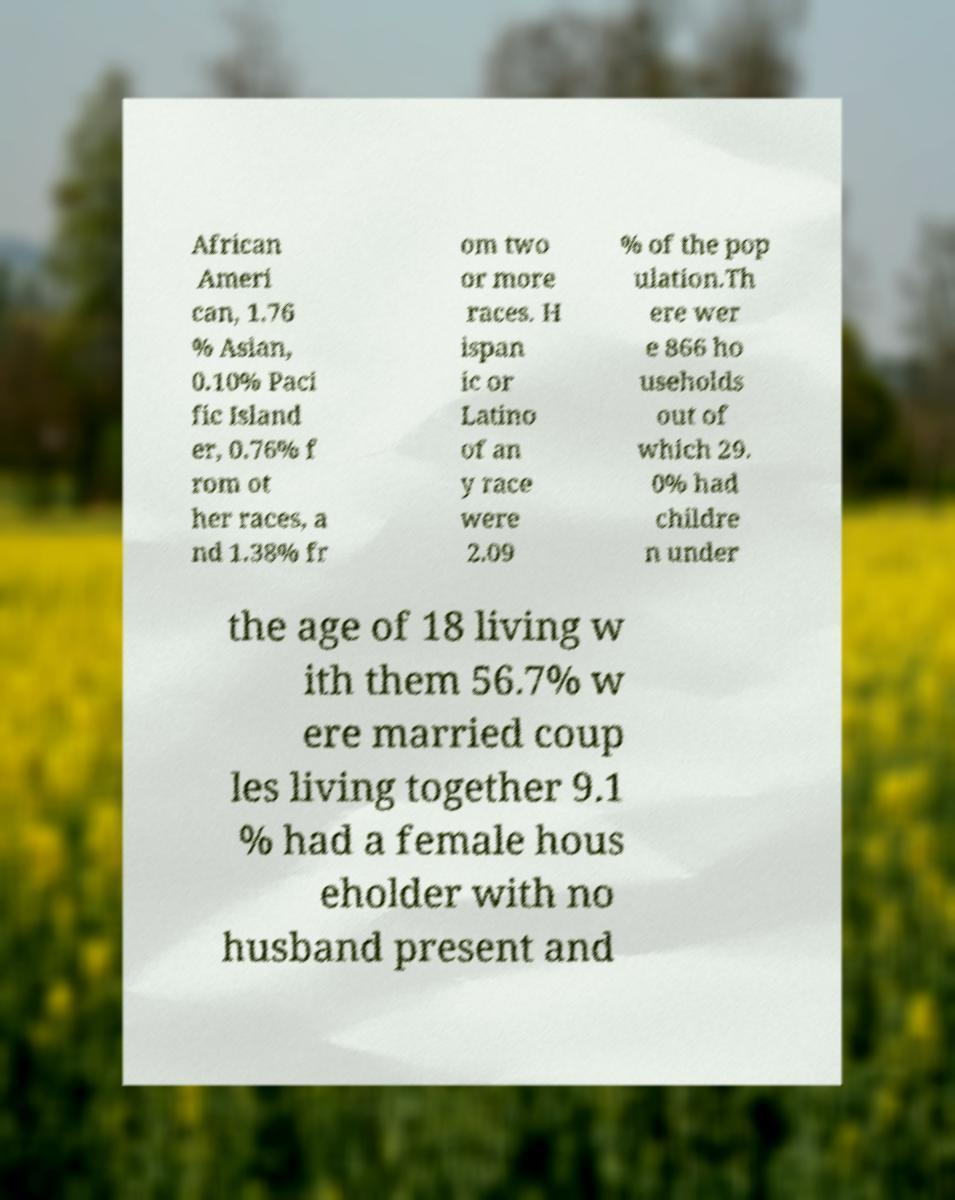What messages or text are displayed in this image? I need them in a readable, typed format. African Ameri can, 1.76 % Asian, 0.10% Paci fic Island er, 0.76% f rom ot her races, a nd 1.38% fr om two or more races. H ispan ic or Latino of an y race were 2.09 % of the pop ulation.Th ere wer e 866 ho useholds out of which 29. 0% had childre n under the age of 18 living w ith them 56.7% w ere married coup les living together 9.1 % had a female hous eholder with no husband present and 